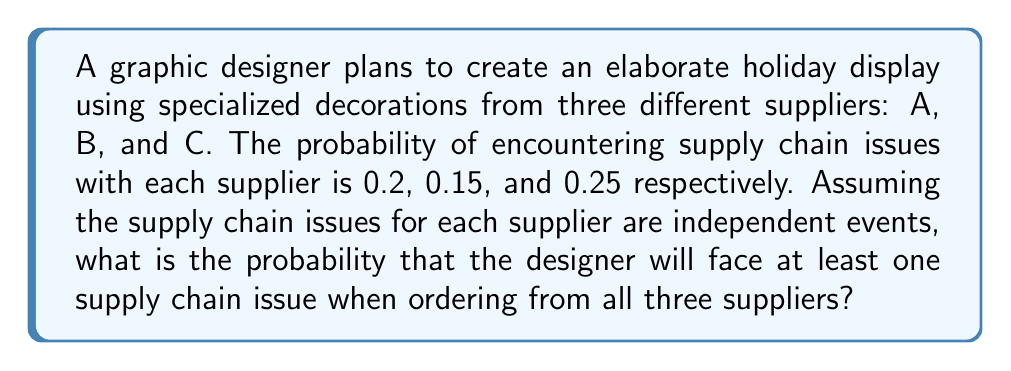Show me your answer to this math problem. Let's approach this step-by-step:

1) First, we need to find the probability of not encountering any supply chain issues. This is easier than calculating the probability of encountering at least one issue directly.

2) For each supplier, the probability of not having an issue is:
   Supplier A: $1 - 0.2 = 0.8$
   Supplier B: $1 - 0.15 = 0.85$
   Supplier C: $1 - 0.25 = 0.75$

3) Since the events are independent, we can multiply these probabilities to find the probability of having no issues with any supplier:

   $P(\text{no issues}) = 0.8 \times 0.85 \times 0.75 = 0.51$

4) Now, the probability of encountering at least one supply chain issue is the complement of having no issues:

   $P(\text{at least one issue}) = 1 - P(\text{no issues})$

5) Therefore:

   $P(\text{at least one issue}) = 1 - 0.51 = 0.49$

6) Converting to a percentage:

   $0.49 \times 100\% = 49\%$
Answer: 49% 